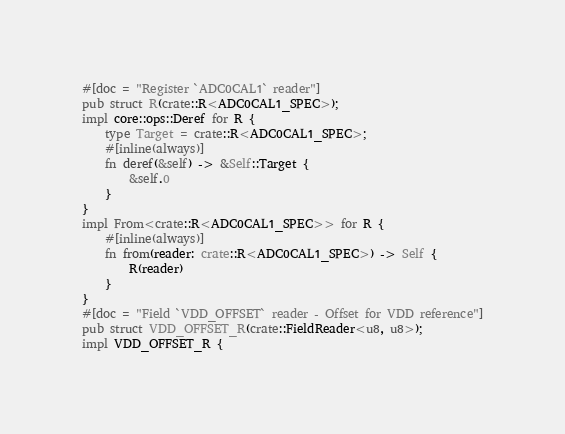Convert code to text. <code><loc_0><loc_0><loc_500><loc_500><_Rust_>#[doc = "Register `ADC0CAL1` reader"]
pub struct R(crate::R<ADC0CAL1_SPEC>);
impl core::ops::Deref for R {
    type Target = crate::R<ADC0CAL1_SPEC>;
    #[inline(always)]
    fn deref(&self) -> &Self::Target {
        &self.0
    }
}
impl From<crate::R<ADC0CAL1_SPEC>> for R {
    #[inline(always)]
    fn from(reader: crate::R<ADC0CAL1_SPEC>) -> Self {
        R(reader)
    }
}
#[doc = "Field `VDD_OFFSET` reader - Offset for VDD reference"]
pub struct VDD_OFFSET_R(crate::FieldReader<u8, u8>);
impl VDD_OFFSET_R {</code> 